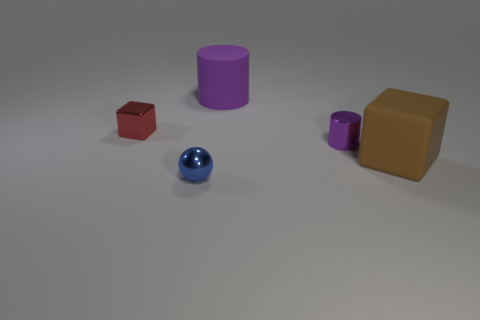Does the small cylinder have the same color as the big matte cylinder?
Give a very brief answer. Yes. What size is the brown object that is the same material as the large purple thing?
Offer a terse response. Large. There is a metallic object right of the small blue shiny object; does it have the same color as the big rubber cylinder?
Provide a short and direct response. Yes. There is a shiny object to the right of the big purple rubber thing; does it have the same shape as the big object in front of the tiny cylinder?
Ensure brevity in your answer.  No. How big is the cube that is behind the tiny purple metal object?
Your answer should be very brief. Small. There is a rubber thing in front of the block on the left side of the big brown object; how big is it?
Your answer should be compact. Large. Is the number of small purple shiny cylinders greater than the number of blocks?
Make the answer very short. No. Is the number of tiny metallic blocks to the left of the big purple thing greater than the number of small blocks that are in front of the blue object?
Make the answer very short. Yes. There is a metal thing that is on the left side of the purple shiny object and in front of the tiny shiny cube; how big is it?
Keep it short and to the point. Small. What number of cylinders have the same size as the brown block?
Your answer should be compact. 1. 